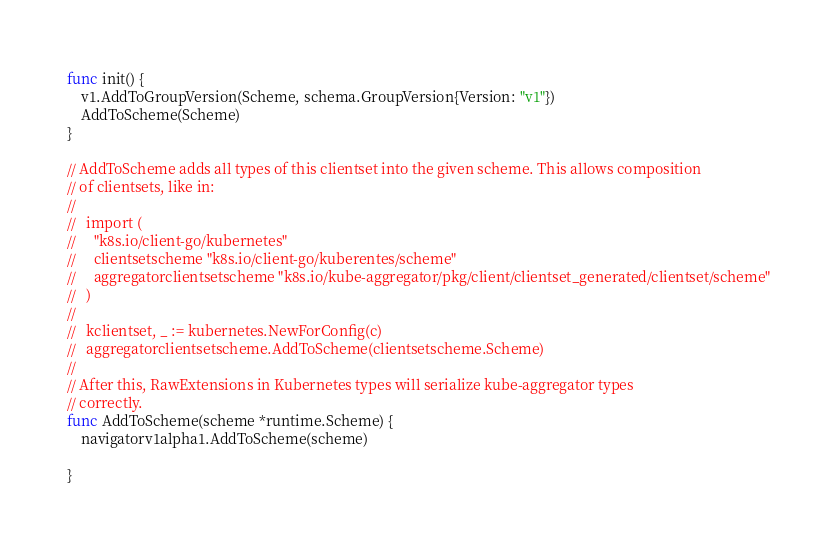<code> <loc_0><loc_0><loc_500><loc_500><_Go_>
func init() {
	v1.AddToGroupVersion(Scheme, schema.GroupVersion{Version: "v1"})
	AddToScheme(Scheme)
}

// AddToScheme adds all types of this clientset into the given scheme. This allows composition
// of clientsets, like in:
//
//   import (
//     "k8s.io/client-go/kubernetes"
//     clientsetscheme "k8s.io/client-go/kuberentes/scheme"
//     aggregatorclientsetscheme "k8s.io/kube-aggregator/pkg/client/clientset_generated/clientset/scheme"
//   )
//
//   kclientset, _ := kubernetes.NewForConfig(c)
//   aggregatorclientsetscheme.AddToScheme(clientsetscheme.Scheme)
//
// After this, RawExtensions in Kubernetes types will serialize kube-aggregator types
// correctly.
func AddToScheme(scheme *runtime.Scheme) {
	navigatorv1alpha1.AddToScheme(scheme)

}
</code> 